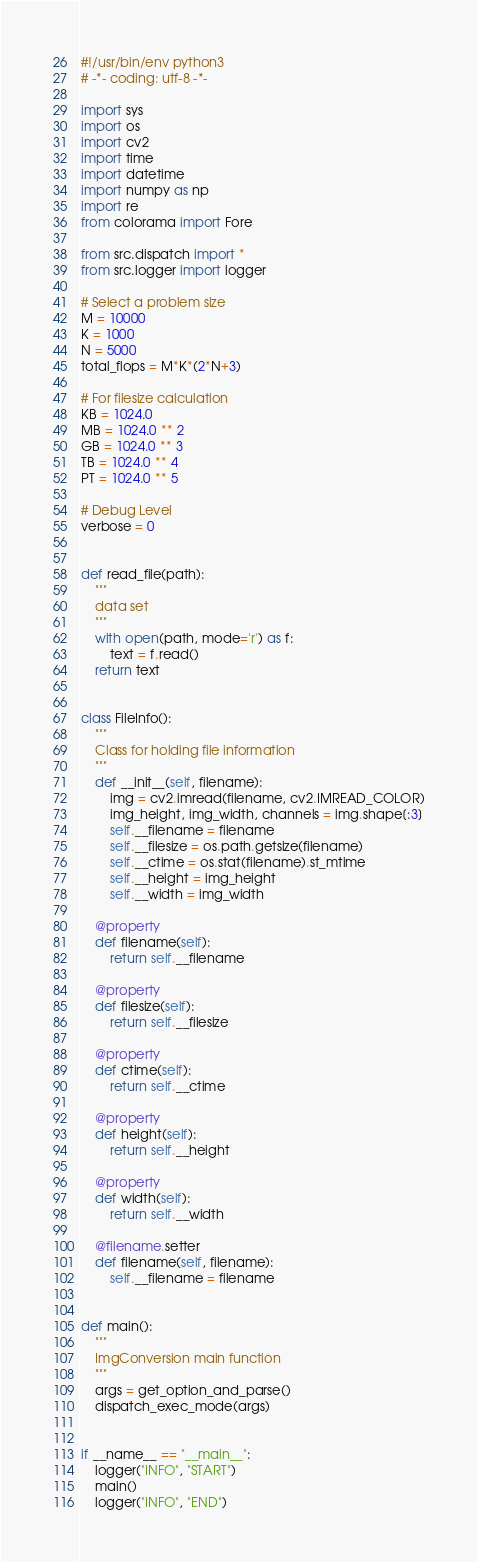<code> <loc_0><loc_0><loc_500><loc_500><_Python_>#!/usr/bin/env python3
# -*- coding: utf-8 -*-

import sys
import os
import cv2
import time
import datetime
import numpy as np
import re
from colorama import Fore

from src.dispatch import *
from src.logger import logger

# Select a problem size
M = 10000
K = 1000
N = 5000
total_flops = M*K*(2*N+3)

# For filesize calculation
KB = 1024.0
MB = 1024.0 ** 2
GB = 1024.0 ** 3
TB = 1024.0 ** 4
PT = 1024.0 ** 5

# Debug Level
verbose = 0


def read_file(path):
    """
    data set
    """
    with open(path, mode='r') as f:
        text = f.read()
    return text


class FileInfo():
    """
    Class for holding file information
    """
    def __init__(self, filename):
        img = cv2.imread(filename, cv2.IMREAD_COLOR)
        img_height, img_width, channels = img.shape[:3]
        self.__filename = filename
        self.__filesize = os.path.getsize(filename)
        self.__ctime = os.stat(filename).st_mtime
        self.__height = img_height
        self.__width = img_width

    @property
    def filename(self):
        return self.__filename

    @property
    def filesize(self):
        return self.__filesize

    @property
    def ctime(self):
        return self.__ctime

    @property
    def height(self):
        return self.__height

    @property
    def width(self):
        return self.__width

    @filename.setter
    def filename(self, filename):
        self.__filename = filename


def main():
    """
    ImgConversion main function
    """
    args = get_option_and_parse()
    dispatch_exec_mode(args)


if __name__ == "__main__":
    logger("INFO", "START")
    main()
    logger("INFO", "END")
</code> 